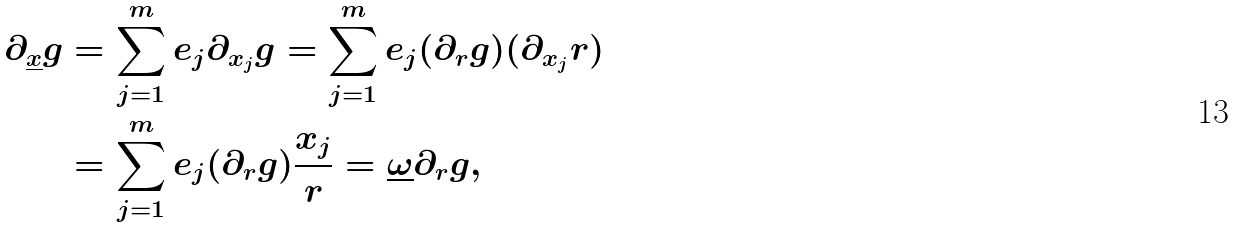Convert formula to latex. <formula><loc_0><loc_0><loc_500><loc_500>\partial _ { \underline { x } } g & = \sum _ { j = 1 } ^ { m } e _ { j } \partial _ { x _ { j } } g = \sum _ { j = 1 } ^ { m } e _ { j } ( \partial _ { r } g ) ( \partial _ { x _ { j } } r ) \\ & = \sum _ { j = 1 } ^ { m } e _ { j } ( \partial _ { r } g ) \frac { x _ { j } } { r } = \underline { \omega } \partial _ { r } g ,</formula> 